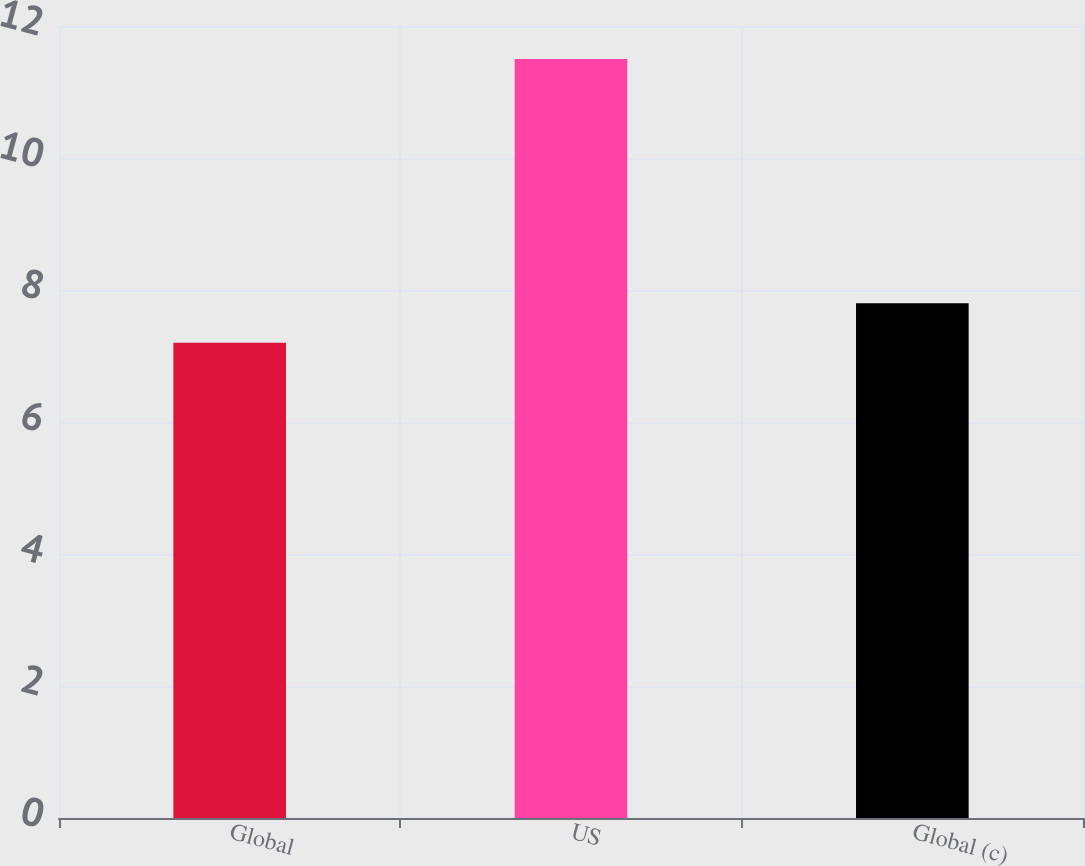Convert chart. <chart><loc_0><loc_0><loc_500><loc_500><bar_chart><fcel>Global<fcel>US<fcel>Global (c)<nl><fcel>7.2<fcel>11.5<fcel>7.8<nl></chart> 